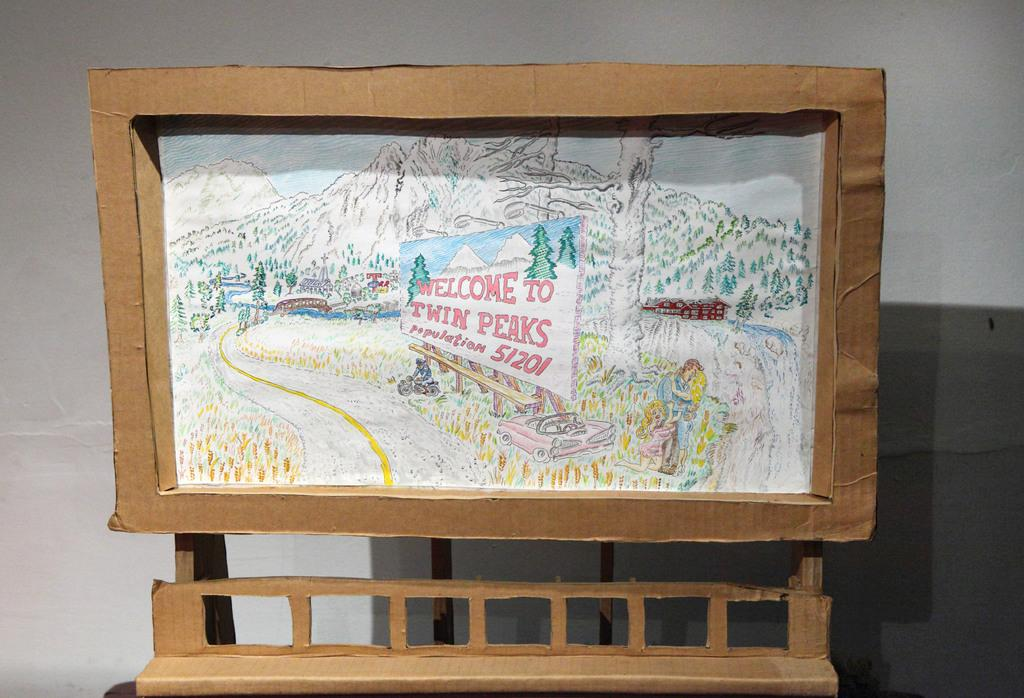Provide a one-sentence caption for the provided image. A cardboard frame has a drawing of a mountain with a sign that says Welcome to Twin Peaks. 